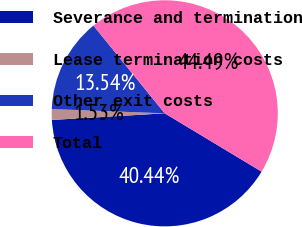Convert chart. <chart><loc_0><loc_0><loc_500><loc_500><pie_chart><fcel>Severance and termination<fcel>Lease termination costs<fcel>Other exit costs<fcel>Total<nl><fcel>40.44%<fcel>1.53%<fcel>13.54%<fcel>44.49%<nl></chart> 